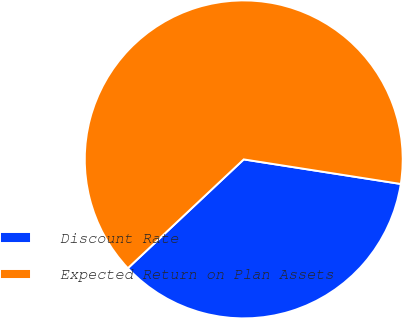Convert chart to OTSL. <chart><loc_0><loc_0><loc_500><loc_500><pie_chart><fcel>Discount Rate<fcel>Expected Return on Plan Assets<nl><fcel>35.53%<fcel>64.47%<nl></chart> 